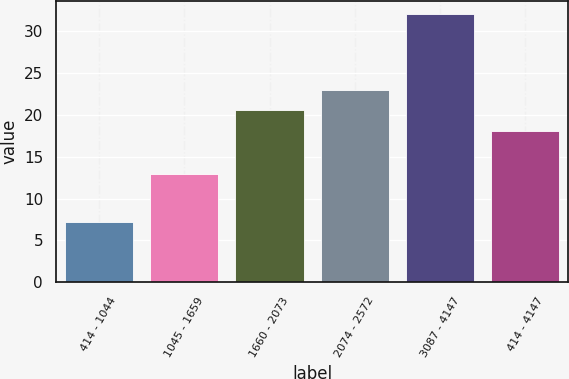<chart> <loc_0><loc_0><loc_500><loc_500><bar_chart><fcel>414 - 1044<fcel>1045 - 1659<fcel>1660 - 2073<fcel>2074 - 2572<fcel>3087 - 4147<fcel>414 - 4147<nl><fcel>7.24<fcel>12.95<fcel>20.53<fcel>23.01<fcel>32.04<fcel>18.05<nl></chart> 